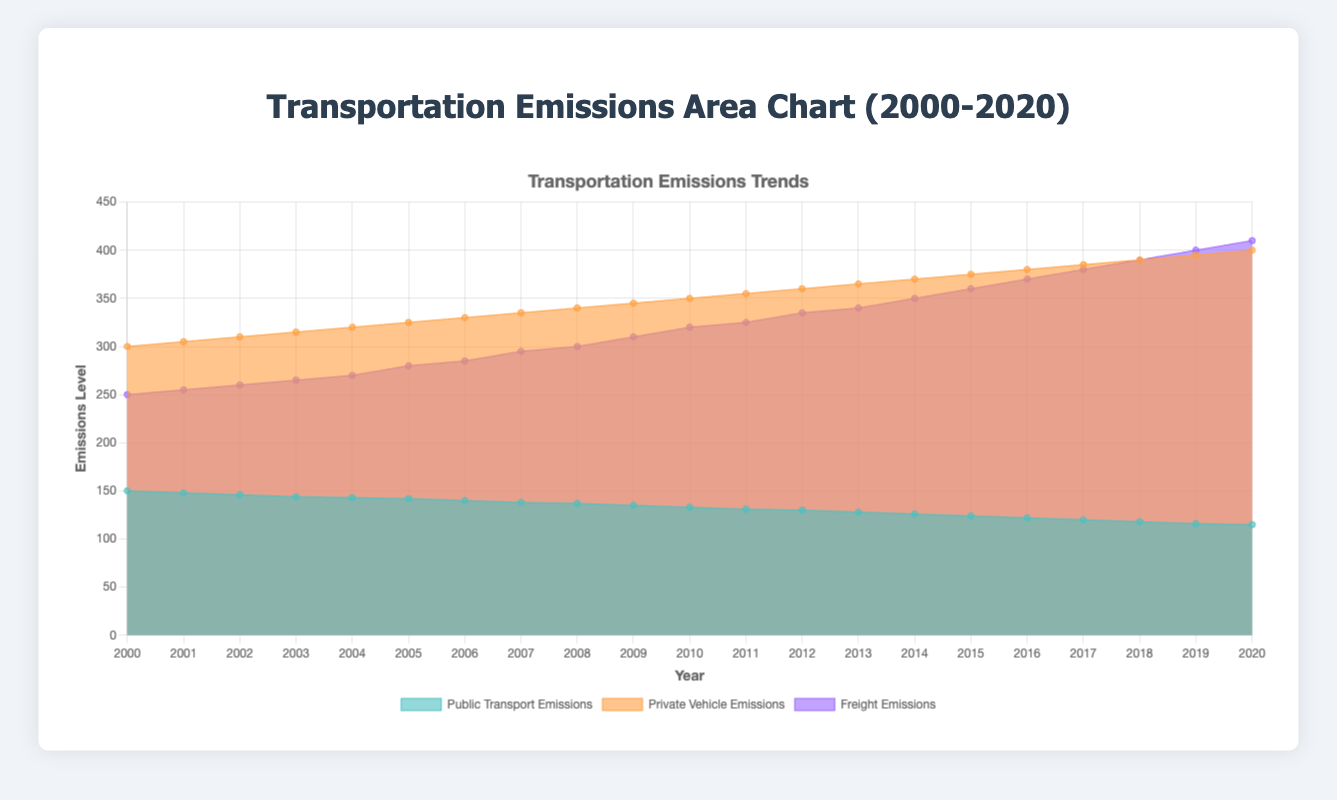What is the title of the chart? The title of the chart is usually displayed prominently at the top. In this figure, it is "Transportation Emissions Area Chart (2000-2020)".
Answer: "Transportation Emissions Area Chart (2000-2020)" What are the three sources of emissions shown in the chart? The labels in the legend at the bottom of the chart identify the three sources of emissions: Public Transport Emissions, Private Vehicle Emissions, and Freight Emissions.
Answer: Public Transport Emissions, Private Vehicle Emissions, Freight Emissions Between which years does the chart show data? The x-axis labels show the range of years from 2000 to 2020.
Answer: 2000 to 2020 Which transportation source has the highest emissions level in 2020? By looking at the y-axis level at the furthest right side of the chart, Freight Emissions appear to be the highest.
Answer: Freight Emissions How do the emissions from public transport change over the 20-year span? Track the area labeled with the color for public transport. The data shows a decreasing trend from 150 to 115 over the years 2000 to 2020.
Answer: Decreasing What is the difference between the emissions from private vehicles and public transport in 2010? Locate the 2010 data points for both sources. Public transport emissions are 133, and private vehicle emissions are 350. The difference is 350 - 133 = 217.
Answer: 217 Which two transportation sources had emissions levels equal in any year? Check for overlapping or equidistant data points between the areas. In 2007, private vehicle emissions (335) and freight emissions (295) were relatively close but not equal. In 2016 and afterwards, freight emissions surpass or equal private vehicle emissions around 2018 (390).
Answer: Private vehicles and freight in 2018 What is the average emissions level for freight over the 20-year span? Sum up the freight emissions for each year: (250+255+260+265+270+280+285+295+300+310+320+325+335+340+350+360+370+380+390+400+410) = 6670. Divide by the number of years (21). The average is 6670/21 ≈ 317.14.
Answer: 317.14 Compare the trends in emissions for private vehicles and public transport over the years. Private vehicle emissions show an increasing trend from 300 to 400, while public transport emissions show a decreasing trend from 150 to 115. This indicates that private vehicle emissions are rising, and public transport emissions are falling.
Answer: Rising for private vehicles, falling for public transport 